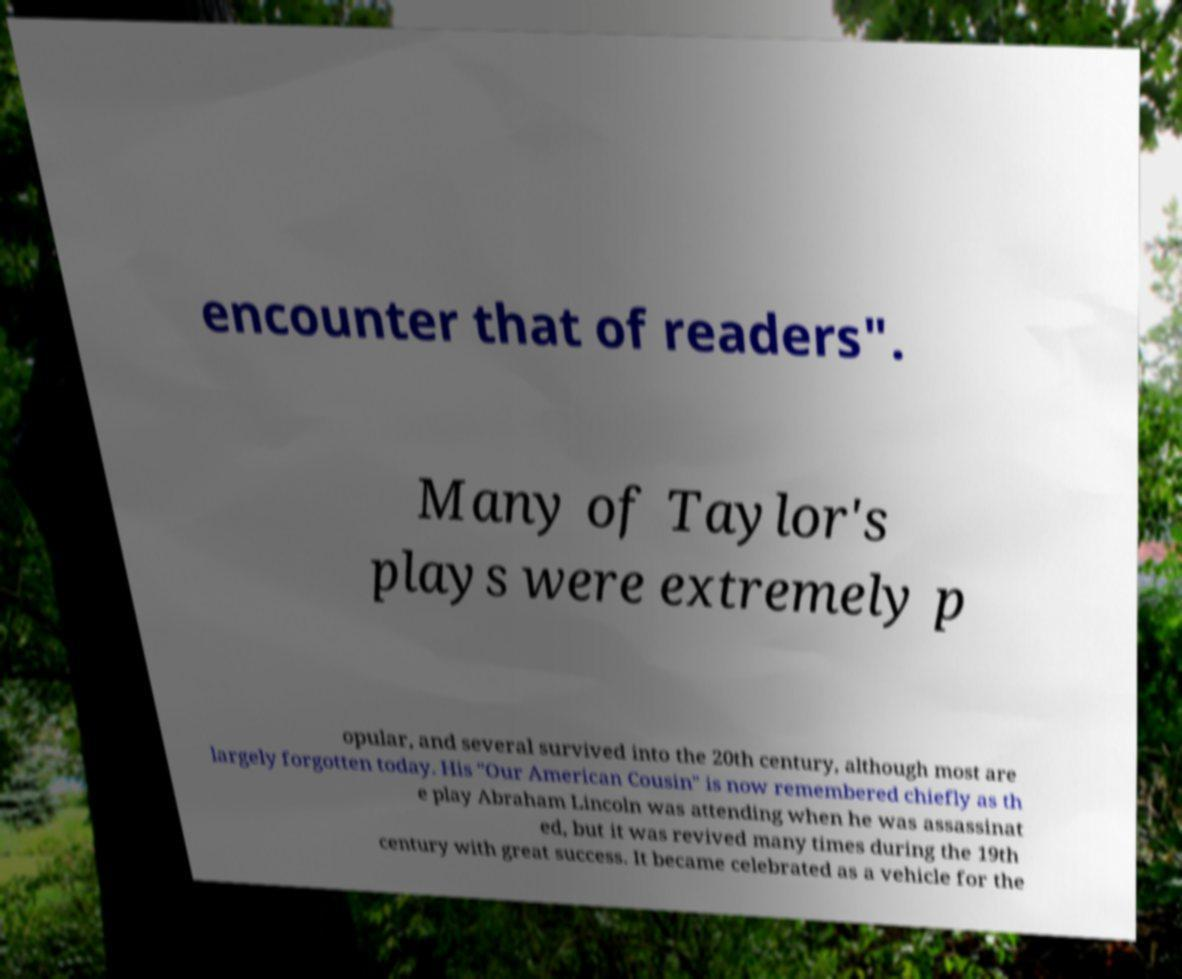Could you assist in decoding the text presented in this image and type it out clearly? encounter that of readers". Many of Taylor's plays were extremely p opular, and several survived into the 20th century, although most are largely forgotten today. His "Our American Cousin" is now remembered chiefly as th e play Abraham Lincoln was attending when he was assassinat ed, but it was revived many times during the 19th century with great success. It became celebrated as a vehicle for the 